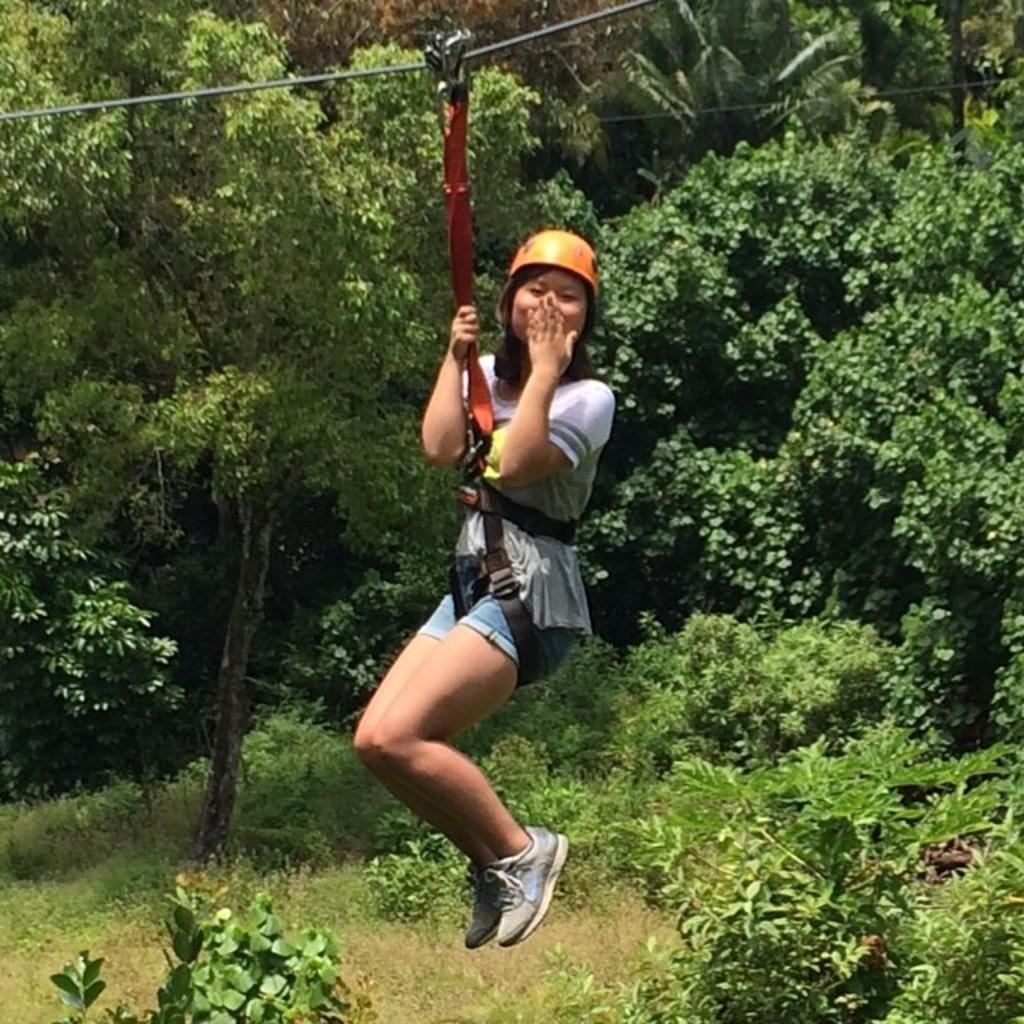Can you describe this image briefly? In this image I can see a woman hanging on a rope with a helmet. She is posing for the picture. I can see trees behind her. 